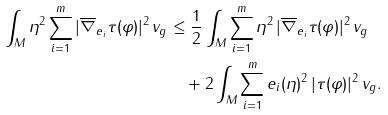Convert formula to latex. <formula><loc_0><loc_0><loc_500><loc_500>\int _ { M } \eta ^ { 2 } \sum _ { i = 1 } ^ { m } | \overline { \nabla } _ { e _ { i } } \tau ( \varphi ) | ^ { 2 } \, v _ { g } & \leq \frac { 1 } { 2 } \int _ { M } \sum _ { i = 1 } ^ { m } \eta ^ { 2 } \, | \overline { \nabla } _ { e _ { i } } \tau ( \varphi ) | ^ { 2 } \, v _ { g } \\ & \quad + 2 \int _ { M } \sum _ { i = 1 } ^ { m } e _ { i } ( \eta ) ^ { 2 } \, | \tau ( \varphi ) | ^ { 2 } \, v _ { g } .</formula> 